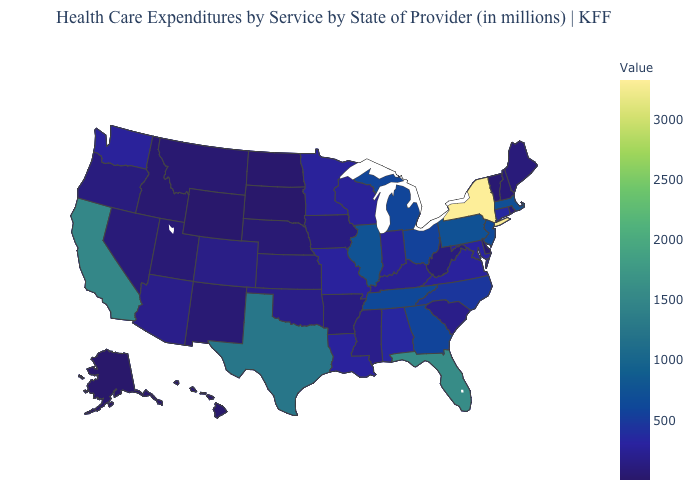Among the states that border Nebraska , which have the lowest value?
Keep it brief. South Dakota. Does the map have missing data?
Quick response, please. No. Which states hav the highest value in the MidWest?
Answer briefly. Illinois. Among the states that border Connecticut , does Rhode Island have the lowest value?
Write a very short answer. Yes. Does New Jersey have a higher value than South Dakota?
Keep it brief. Yes. 